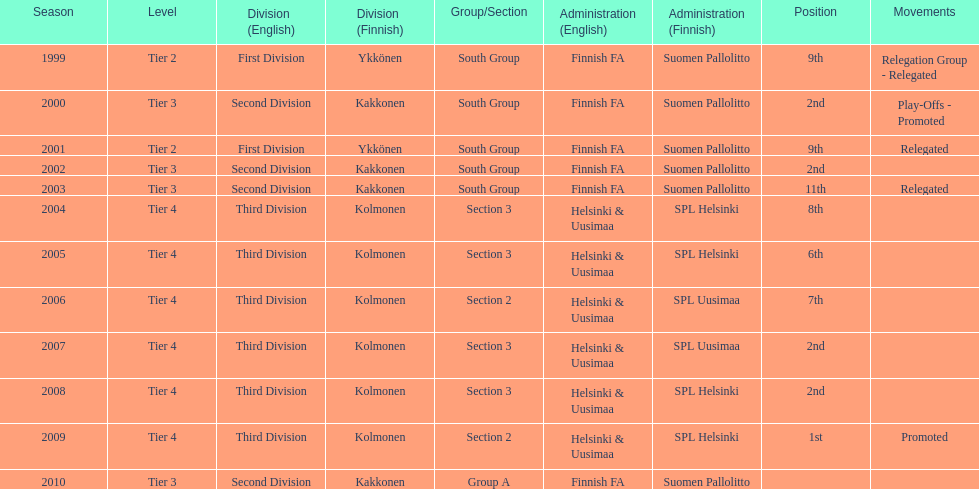How many 2nd positions were there? 4. 